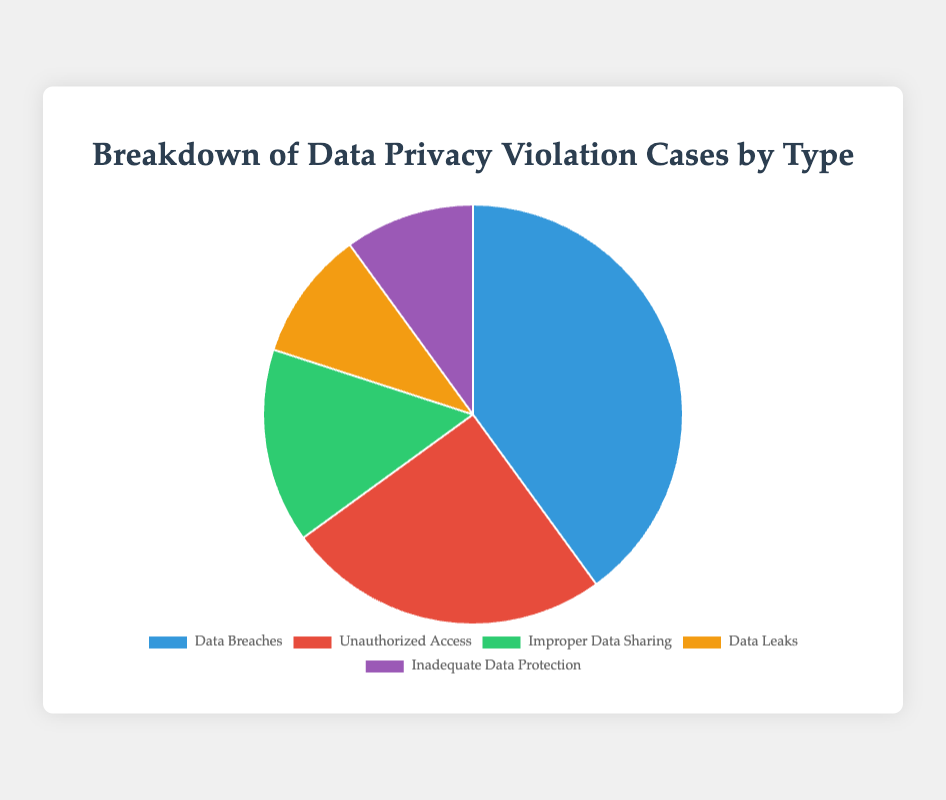What percentage of data privacy violation cases were due to unauthorized access? According to the pie chart, the segment for Unauthorized Access is 25%.
Answer: 25% Which type of data privacy violation is the most common? The largest segment in the pie chart represents Data Breaches, which account for 40% of the cases.
Answer: Data Breaches What is the total percentage of cases accounted for by data leaks and inadequate data protection combined? Data Leaks and Inadequate Data Protection each have a percentage of 10%. Adding these together gives 10% + 10% = 20%.
Answer: 20% How do the percentages of improper data sharing and unauthorized access compare? Improper Data Sharing accounts for 15%, while Unauthorized Access accounts for 25% of the cases. Therefore, Unauthorized Access is 10% higher than Improper Data Sharing.
Answer: Unauthorized Access is 10% higher Calculate the difference between the percentage of data breaches and improper data sharing cases. Data Breaches account for 40% and Improper Data Sharing for 15%. The difference is 40% - 15% = 25%.
Answer: 25% What proportion of the chart is represented by the smallest segments? The pie chart shows the smallest segments as Data Leaks and Inadequate Data Protection, each at 10%, for a total of 10% + 10% = 20%.
Answer: 20% Identify the color used to represent the highest percentage in the pie chart. The color used for the largest segment, which is Data Breaches, is blue.
Answer: Blue Which data privacy violation types collectively account for half of the total cases? Data Breaches (40%) and Unauthorized Access (25%) together sum up to 65%, which exceeds half of the total cases. Therefore, only Data Breaches and Unauthorized Access combined cover over half of the total cases.
Answer: Data Breaches and Unauthorized Access 